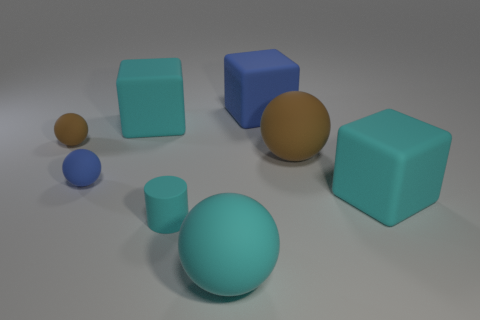There is a sphere that is both behind the rubber cylinder and right of the tiny cylinder; what is its size?
Make the answer very short. Large. Do the small rubber cylinder and the large rubber sphere in front of the small matte cylinder have the same color?
Offer a very short reply. Yes. Is there a tiny cyan object that has the same shape as the large brown thing?
Ensure brevity in your answer.  No. How many objects are either brown metallic spheres or brown things behind the cyan sphere?
Ensure brevity in your answer.  2. What number of other objects are the same material as the big brown sphere?
Ensure brevity in your answer.  7. What number of things are either cyan cubes or large yellow metal cylinders?
Your answer should be compact. 2. Are there more tiny blue rubber spheres that are in front of the cyan sphere than big rubber objects that are in front of the large blue block?
Keep it short and to the point. No. There is a rubber block that is in front of the tiny brown ball; does it have the same color as the rubber ball in front of the tiny cyan matte thing?
Your answer should be compact. Yes. There is a blue rubber object to the right of the blue object in front of the matte block that is on the left side of the big blue block; how big is it?
Provide a short and direct response. Large. There is another tiny rubber thing that is the same shape as the tiny blue rubber thing; what is its color?
Your response must be concise. Brown. 